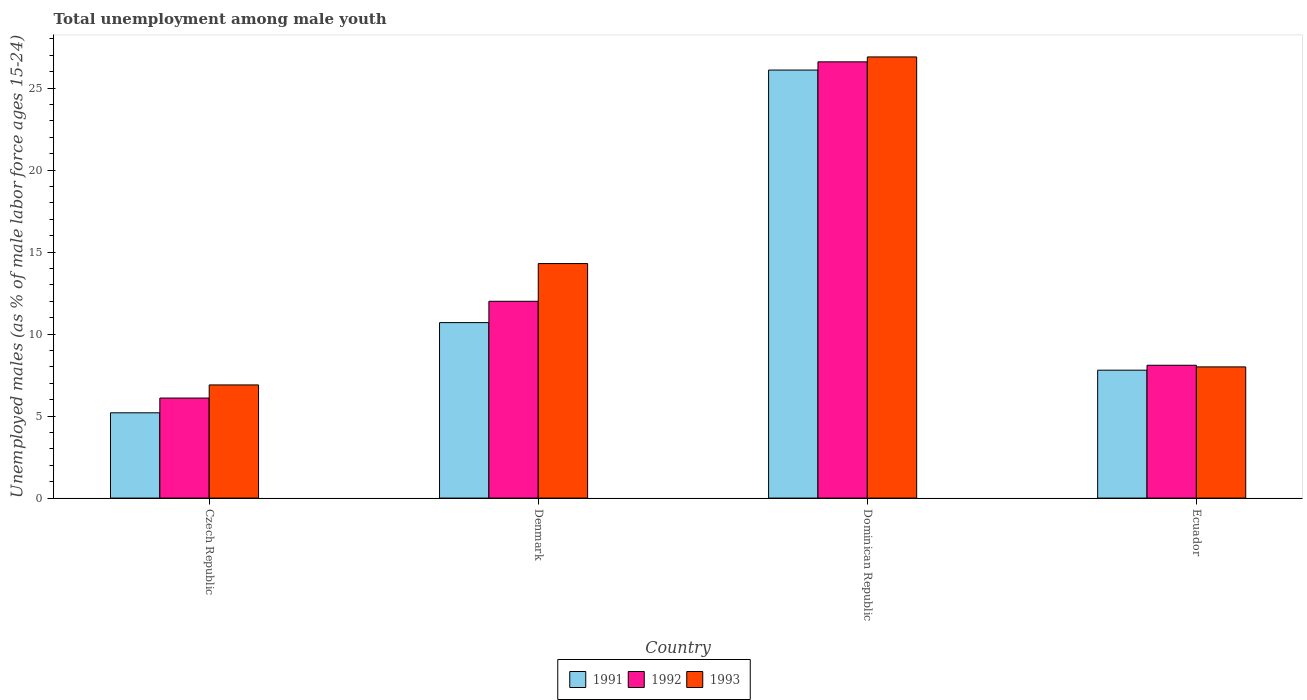Are the number of bars per tick equal to the number of legend labels?
Give a very brief answer. Yes. Are the number of bars on each tick of the X-axis equal?
Make the answer very short. Yes. How many bars are there on the 4th tick from the left?
Offer a terse response. 3. What is the label of the 4th group of bars from the left?
Keep it short and to the point. Ecuador. What is the percentage of unemployed males in in 1991 in Czech Republic?
Provide a succinct answer. 5.2. Across all countries, what is the maximum percentage of unemployed males in in 1993?
Ensure brevity in your answer.  26.9. Across all countries, what is the minimum percentage of unemployed males in in 1993?
Your answer should be compact. 6.9. In which country was the percentage of unemployed males in in 1991 maximum?
Offer a terse response. Dominican Republic. In which country was the percentage of unemployed males in in 1993 minimum?
Ensure brevity in your answer.  Czech Republic. What is the total percentage of unemployed males in in 1992 in the graph?
Your answer should be very brief. 52.8. What is the difference between the percentage of unemployed males in in 1993 in Dominican Republic and that in Ecuador?
Offer a terse response. 18.9. What is the difference between the percentage of unemployed males in in 1991 in Ecuador and the percentage of unemployed males in in 1993 in Dominican Republic?
Make the answer very short. -19.1. What is the average percentage of unemployed males in in 1991 per country?
Provide a short and direct response. 12.45. What is the difference between the percentage of unemployed males in of/in 1991 and percentage of unemployed males in of/in 1993 in Dominican Republic?
Your answer should be compact. -0.8. What is the ratio of the percentage of unemployed males in in 1993 in Denmark to that in Dominican Republic?
Give a very brief answer. 0.53. Is the percentage of unemployed males in in 1993 in Czech Republic less than that in Denmark?
Give a very brief answer. Yes. Is the difference between the percentage of unemployed males in in 1991 in Czech Republic and Dominican Republic greater than the difference between the percentage of unemployed males in in 1993 in Czech Republic and Dominican Republic?
Your response must be concise. No. What is the difference between the highest and the second highest percentage of unemployed males in in 1992?
Keep it short and to the point. -18.5. What is the difference between the highest and the lowest percentage of unemployed males in in 1991?
Provide a short and direct response. 20.9. Is the sum of the percentage of unemployed males in in 1993 in Dominican Republic and Ecuador greater than the maximum percentage of unemployed males in in 1992 across all countries?
Your answer should be compact. Yes. What does the 1st bar from the right in Denmark represents?
Give a very brief answer. 1993. Is it the case that in every country, the sum of the percentage of unemployed males in in 1993 and percentage of unemployed males in in 1991 is greater than the percentage of unemployed males in in 1992?
Offer a terse response. Yes. What is the difference between two consecutive major ticks on the Y-axis?
Make the answer very short. 5. Does the graph contain grids?
Your answer should be very brief. No. Where does the legend appear in the graph?
Provide a succinct answer. Bottom center. How many legend labels are there?
Keep it short and to the point. 3. What is the title of the graph?
Your answer should be very brief. Total unemployment among male youth. What is the label or title of the X-axis?
Offer a very short reply. Country. What is the label or title of the Y-axis?
Give a very brief answer. Unemployed males (as % of male labor force ages 15-24). What is the Unemployed males (as % of male labor force ages 15-24) of 1991 in Czech Republic?
Offer a terse response. 5.2. What is the Unemployed males (as % of male labor force ages 15-24) of 1992 in Czech Republic?
Give a very brief answer. 6.1. What is the Unemployed males (as % of male labor force ages 15-24) in 1993 in Czech Republic?
Offer a very short reply. 6.9. What is the Unemployed males (as % of male labor force ages 15-24) in 1991 in Denmark?
Your answer should be compact. 10.7. What is the Unemployed males (as % of male labor force ages 15-24) of 1993 in Denmark?
Make the answer very short. 14.3. What is the Unemployed males (as % of male labor force ages 15-24) of 1991 in Dominican Republic?
Your answer should be compact. 26.1. What is the Unemployed males (as % of male labor force ages 15-24) in 1992 in Dominican Republic?
Make the answer very short. 26.6. What is the Unemployed males (as % of male labor force ages 15-24) in 1993 in Dominican Republic?
Keep it short and to the point. 26.9. What is the Unemployed males (as % of male labor force ages 15-24) in 1991 in Ecuador?
Your response must be concise. 7.8. What is the Unemployed males (as % of male labor force ages 15-24) in 1992 in Ecuador?
Your answer should be compact. 8.1. What is the Unemployed males (as % of male labor force ages 15-24) in 1993 in Ecuador?
Offer a terse response. 8. Across all countries, what is the maximum Unemployed males (as % of male labor force ages 15-24) in 1991?
Ensure brevity in your answer.  26.1. Across all countries, what is the maximum Unemployed males (as % of male labor force ages 15-24) of 1992?
Offer a very short reply. 26.6. Across all countries, what is the maximum Unemployed males (as % of male labor force ages 15-24) of 1993?
Your response must be concise. 26.9. Across all countries, what is the minimum Unemployed males (as % of male labor force ages 15-24) in 1991?
Give a very brief answer. 5.2. Across all countries, what is the minimum Unemployed males (as % of male labor force ages 15-24) of 1992?
Make the answer very short. 6.1. Across all countries, what is the minimum Unemployed males (as % of male labor force ages 15-24) of 1993?
Provide a succinct answer. 6.9. What is the total Unemployed males (as % of male labor force ages 15-24) in 1991 in the graph?
Make the answer very short. 49.8. What is the total Unemployed males (as % of male labor force ages 15-24) of 1992 in the graph?
Offer a terse response. 52.8. What is the total Unemployed males (as % of male labor force ages 15-24) in 1993 in the graph?
Your answer should be very brief. 56.1. What is the difference between the Unemployed males (as % of male labor force ages 15-24) in 1993 in Czech Republic and that in Denmark?
Your response must be concise. -7.4. What is the difference between the Unemployed males (as % of male labor force ages 15-24) in 1991 in Czech Republic and that in Dominican Republic?
Offer a terse response. -20.9. What is the difference between the Unemployed males (as % of male labor force ages 15-24) in 1992 in Czech Republic and that in Dominican Republic?
Give a very brief answer. -20.5. What is the difference between the Unemployed males (as % of male labor force ages 15-24) of 1992 in Czech Republic and that in Ecuador?
Make the answer very short. -2. What is the difference between the Unemployed males (as % of male labor force ages 15-24) of 1993 in Czech Republic and that in Ecuador?
Your answer should be very brief. -1.1. What is the difference between the Unemployed males (as % of male labor force ages 15-24) in 1991 in Denmark and that in Dominican Republic?
Your response must be concise. -15.4. What is the difference between the Unemployed males (as % of male labor force ages 15-24) in 1992 in Denmark and that in Dominican Republic?
Provide a short and direct response. -14.6. What is the difference between the Unemployed males (as % of male labor force ages 15-24) of 1993 in Denmark and that in Dominican Republic?
Offer a terse response. -12.6. What is the difference between the Unemployed males (as % of male labor force ages 15-24) in 1991 in Denmark and that in Ecuador?
Keep it short and to the point. 2.9. What is the difference between the Unemployed males (as % of male labor force ages 15-24) in 1991 in Dominican Republic and that in Ecuador?
Offer a terse response. 18.3. What is the difference between the Unemployed males (as % of male labor force ages 15-24) of 1993 in Dominican Republic and that in Ecuador?
Make the answer very short. 18.9. What is the difference between the Unemployed males (as % of male labor force ages 15-24) in 1991 in Czech Republic and the Unemployed males (as % of male labor force ages 15-24) in 1992 in Dominican Republic?
Make the answer very short. -21.4. What is the difference between the Unemployed males (as % of male labor force ages 15-24) of 1991 in Czech Republic and the Unemployed males (as % of male labor force ages 15-24) of 1993 in Dominican Republic?
Give a very brief answer. -21.7. What is the difference between the Unemployed males (as % of male labor force ages 15-24) in 1992 in Czech Republic and the Unemployed males (as % of male labor force ages 15-24) in 1993 in Dominican Republic?
Ensure brevity in your answer.  -20.8. What is the difference between the Unemployed males (as % of male labor force ages 15-24) in 1991 in Czech Republic and the Unemployed males (as % of male labor force ages 15-24) in 1993 in Ecuador?
Offer a terse response. -2.8. What is the difference between the Unemployed males (as % of male labor force ages 15-24) in 1992 in Czech Republic and the Unemployed males (as % of male labor force ages 15-24) in 1993 in Ecuador?
Give a very brief answer. -1.9. What is the difference between the Unemployed males (as % of male labor force ages 15-24) of 1991 in Denmark and the Unemployed males (as % of male labor force ages 15-24) of 1992 in Dominican Republic?
Your answer should be very brief. -15.9. What is the difference between the Unemployed males (as % of male labor force ages 15-24) in 1991 in Denmark and the Unemployed males (as % of male labor force ages 15-24) in 1993 in Dominican Republic?
Keep it short and to the point. -16.2. What is the difference between the Unemployed males (as % of male labor force ages 15-24) of 1992 in Denmark and the Unemployed males (as % of male labor force ages 15-24) of 1993 in Dominican Republic?
Your answer should be compact. -14.9. What is the difference between the Unemployed males (as % of male labor force ages 15-24) in 1991 in Denmark and the Unemployed males (as % of male labor force ages 15-24) in 1992 in Ecuador?
Ensure brevity in your answer.  2.6. What is the difference between the Unemployed males (as % of male labor force ages 15-24) in 1992 in Dominican Republic and the Unemployed males (as % of male labor force ages 15-24) in 1993 in Ecuador?
Provide a succinct answer. 18.6. What is the average Unemployed males (as % of male labor force ages 15-24) of 1991 per country?
Provide a succinct answer. 12.45. What is the average Unemployed males (as % of male labor force ages 15-24) in 1993 per country?
Ensure brevity in your answer.  14.03. What is the difference between the Unemployed males (as % of male labor force ages 15-24) of 1991 and Unemployed males (as % of male labor force ages 15-24) of 1992 in Ecuador?
Provide a succinct answer. -0.3. What is the difference between the Unemployed males (as % of male labor force ages 15-24) in 1992 and Unemployed males (as % of male labor force ages 15-24) in 1993 in Ecuador?
Provide a short and direct response. 0.1. What is the ratio of the Unemployed males (as % of male labor force ages 15-24) in 1991 in Czech Republic to that in Denmark?
Keep it short and to the point. 0.49. What is the ratio of the Unemployed males (as % of male labor force ages 15-24) in 1992 in Czech Republic to that in Denmark?
Provide a short and direct response. 0.51. What is the ratio of the Unemployed males (as % of male labor force ages 15-24) in 1993 in Czech Republic to that in Denmark?
Offer a very short reply. 0.48. What is the ratio of the Unemployed males (as % of male labor force ages 15-24) in 1991 in Czech Republic to that in Dominican Republic?
Give a very brief answer. 0.2. What is the ratio of the Unemployed males (as % of male labor force ages 15-24) in 1992 in Czech Republic to that in Dominican Republic?
Offer a very short reply. 0.23. What is the ratio of the Unemployed males (as % of male labor force ages 15-24) in 1993 in Czech Republic to that in Dominican Republic?
Offer a terse response. 0.26. What is the ratio of the Unemployed males (as % of male labor force ages 15-24) in 1992 in Czech Republic to that in Ecuador?
Provide a short and direct response. 0.75. What is the ratio of the Unemployed males (as % of male labor force ages 15-24) in 1993 in Czech Republic to that in Ecuador?
Your response must be concise. 0.86. What is the ratio of the Unemployed males (as % of male labor force ages 15-24) in 1991 in Denmark to that in Dominican Republic?
Make the answer very short. 0.41. What is the ratio of the Unemployed males (as % of male labor force ages 15-24) of 1992 in Denmark to that in Dominican Republic?
Make the answer very short. 0.45. What is the ratio of the Unemployed males (as % of male labor force ages 15-24) in 1993 in Denmark to that in Dominican Republic?
Keep it short and to the point. 0.53. What is the ratio of the Unemployed males (as % of male labor force ages 15-24) of 1991 in Denmark to that in Ecuador?
Ensure brevity in your answer.  1.37. What is the ratio of the Unemployed males (as % of male labor force ages 15-24) of 1992 in Denmark to that in Ecuador?
Keep it short and to the point. 1.48. What is the ratio of the Unemployed males (as % of male labor force ages 15-24) in 1993 in Denmark to that in Ecuador?
Ensure brevity in your answer.  1.79. What is the ratio of the Unemployed males (as % of male labor force ages 15-24) in 1991 in Dominican Republic to that in Ecuador?
Your response must be concise. 3.35. What is the ratio of the Unemployed males (as % of male labor force ages 15-24) of 1992 in Dominican Republic to that in Ecuador?
Your answer should be very brief. 3.28. What is the ratio of the Unemployed males (as % of male labor force ages 15-24) of 1993 in Dominican Republic to that in Ecuador?
Your answer should be compact. 3.36. What is the difference between the highest and the second highest Unemployed males (as % of male labor force ages 15-24) of 1992?
Give a very brief answer. 14.6. What is the difference between the highest and the second highest Unemployed males (as % of male labor force ages 15-24) of 1993?
Your answer should be very brief. 12.6. What is the difference between the highest and the lowest Unemployed males (as % of male labor force ages 15-24) of 1991?
Offer a very short reply. 20.9. What is the difference between the highest and the lowest Unemployed males (as % of male labor force ages 15-24) of 1993?
Make the answer very short. 20. 